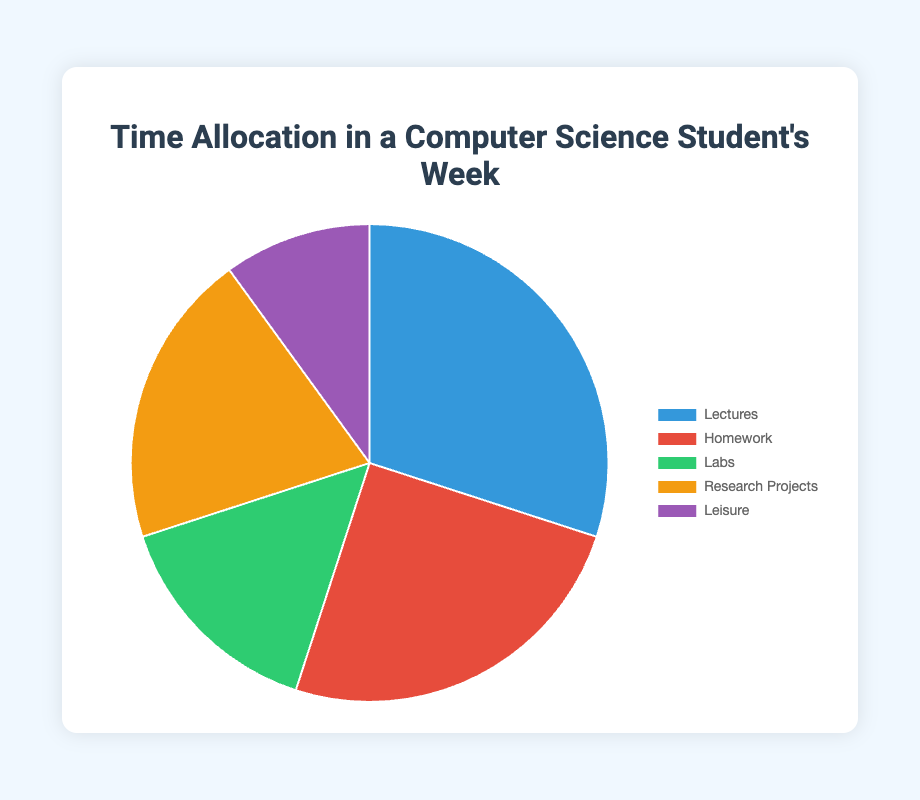What is the percentage of time spent on Lectures? According to the data, Lectures take 30 hours out of the total (30+25+15+20+10) 100 hours. The percentage is calculated as (30/100)*100 = 30%.
Answer: 30% Which activity takes up the smallest portion of the student's weekly time? By observing the pie chart, Leisure is the smallest segment, corresponding to 10 hours.
Answer: Leisure How many more hours are spent on Homework compared to Labs? Homework accounts for 25 hours, while Labs account for 15 hours. The difference is 25 - 15 = 10 hours.
Answer: 10 hours What two activities combined make up half of the student's weekly time allocation? Homework (25 hours) and Research Projects (20 hours) combine to 25 + 20 = 45 hours, which does not equal 50 hours (half of 100). Lectures (30 hours) and Labs (15 hours) combine to 30 + 15 = 45 hours as well. Finally, Lectures (30 hours) and Research Projects (20 hours) combine to 30 + 20 = 50 hours, making Lectures and Research Projects the correct pair.
Answer: Lectures and Research Projects What is the total time spent on Research Projects and Leisure combined? Research Projects take 20 hours and Leisure takes 10 hours. Combined, they make 20 + 10 = 30 hours.
Answer: 30 hours Which activity comes second in terms of time allocation? According to the chart, Homework is the second-largest segment at 25 hours, following Lectures.
Answer: Homework What is the average time spent on each activity? The total time is 100 hours spent across 5 activities. The average time per activity is 100 hours / 5 = 20 hours.
Answer: 20 hours How much more time does the student spend on Lectures compared to Leisure? Lectures account for 30 hours, and Leisure for 10 hours, making the difference 30 - 10 = 20 hours.
Answer: 20 hours Which two activities have the same or almost the same proportion of time allocation? By examining the chart, Research Projects (20%) and Labs (15%) are the closest in allocation but not equal. Another combination is Homework (25%) and Research Projects (20%) with 5% difference.
Answer: Research Projects and Labs 